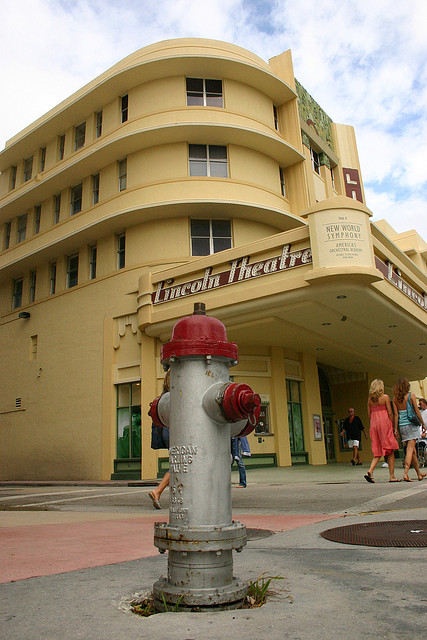Please identify all text content in this image. Lincoln Theatre REW WE 